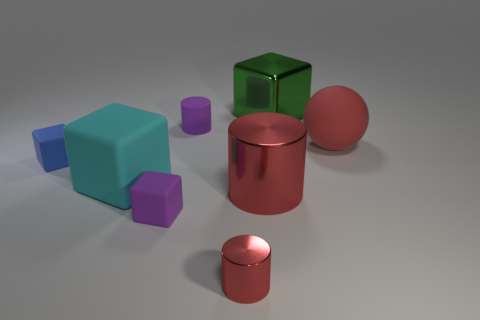There is a purple object in front of the small purple rubber thing that is behind the tiny blue rubber thing; what is its material?
Keep it short and to the point. Rubber. Is the color of the small metal cylinder the same as the big metallic cylinder?
Your answer should be compact. Yes. There is a red object that is right of the big red metallic cylinder; is it the same size as the cylinder that is behind the blue object?
Your response must be concise. No. What number of objects are either small blue matte things left of the big cyan block or rubber objects that are left of the green cube?
Ensure brevity in your answer.  4. Do the large ball and the cube on the right side of the purple cylinder have the same material?
Your answer should be compact. No. The small thing that is both right of the purple rubber cube and behind the tiny metal thing has what shape?
Offer a terse response. Cylinder. What number of other objects are the same color as the big ball?
Offer a terse response. 2. What shape is the large cyan matte object?
Give a very brief answer. Cube. What is the color of the metal object that is in front of the large red cylinder on the right side of the blue object?
Offer a terse response. Red. Does the ball have the same color as the big metal object left of the green shiny cube?
Provide a succinct answer. Yes. 